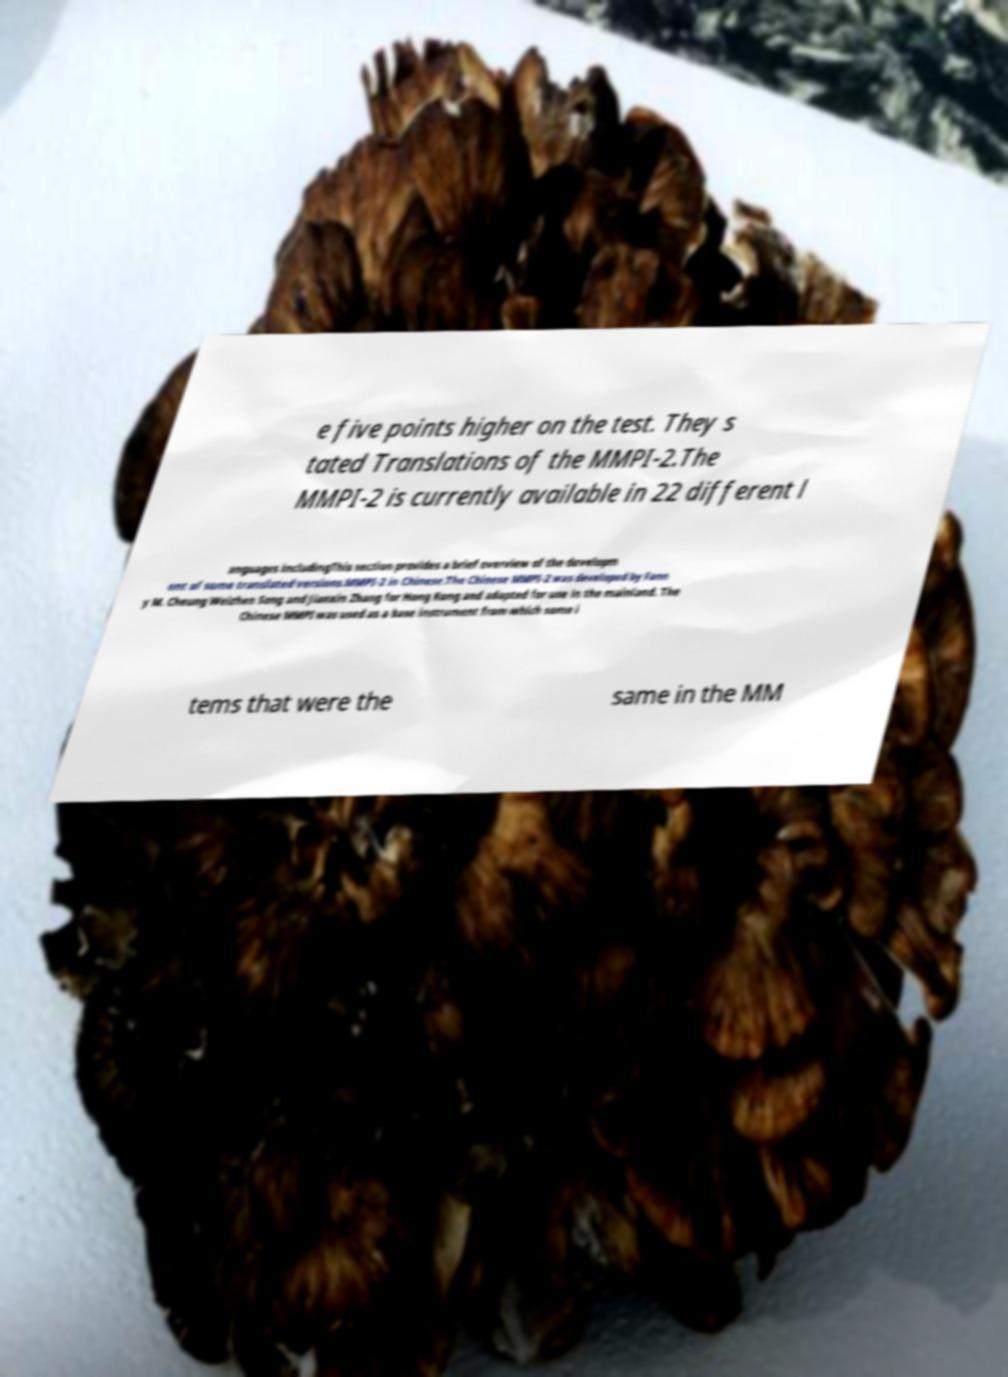Please identify and transcribe the text found in this image. e five points higher on the test. They s tated Translations of the MMPI-2.The MMPI-2 is currently available in 22 different l anguages includingThis section provides a brief overview of the developm ent of some translated versions.MMPI-2 in Chinese.The Chinese MMPI-2 was developed by Fann y M. Cheung Weizhen Song and Jianxin Zhang for Hong Kong and adapted for use in the mainland. The Chinese MMPI was used as a base instrument from which some i tems that were the same in the MM 